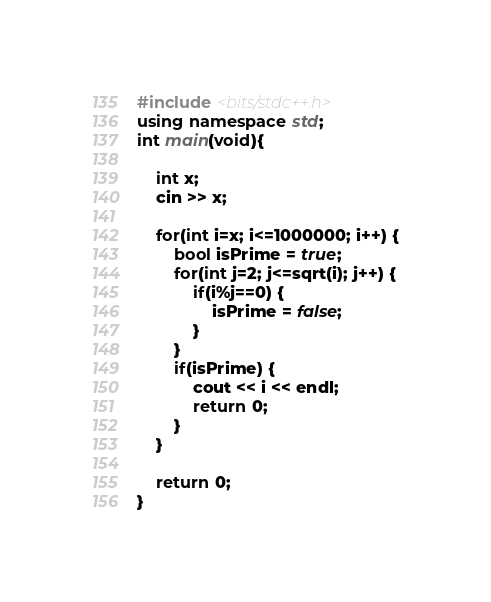Convert code to text. <code><loc_0><loc_0><loc_500><loc_500><_C++_>#include <bits/stdc++.h>
using namespace std;
int main(void){

    int x;
    cin >> x;
    
    for(int i=x; i<=1000000; i++) {
        bool isPrime = true;
        for(int j=2; j<=sqrt(i); j++) {
            if(i%j==0) {
                isPrime = false;
            }
        }
        if(isPrime) {
            cout << i << endl;
            return 0;
        }
    }

    return 0;
}
</code> 